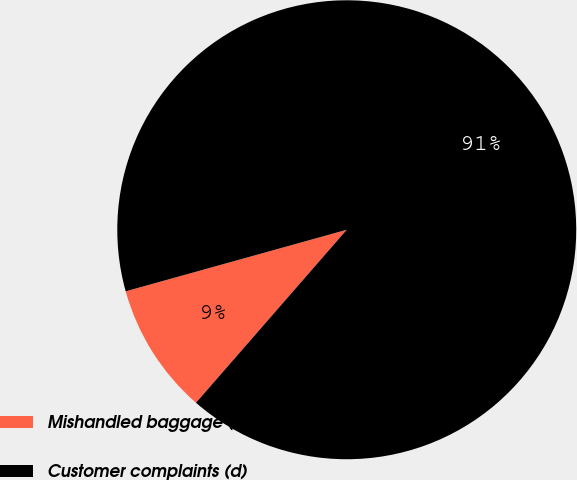Convert chart. <chart><loc_0><loc_0><loc_500><loc_500><pie_chart><fcel>Mishandled baggage (c)<fcel>Customer complaints (d)<nl><fcel>9.27%<fcel>90.73%<nl></chart> 